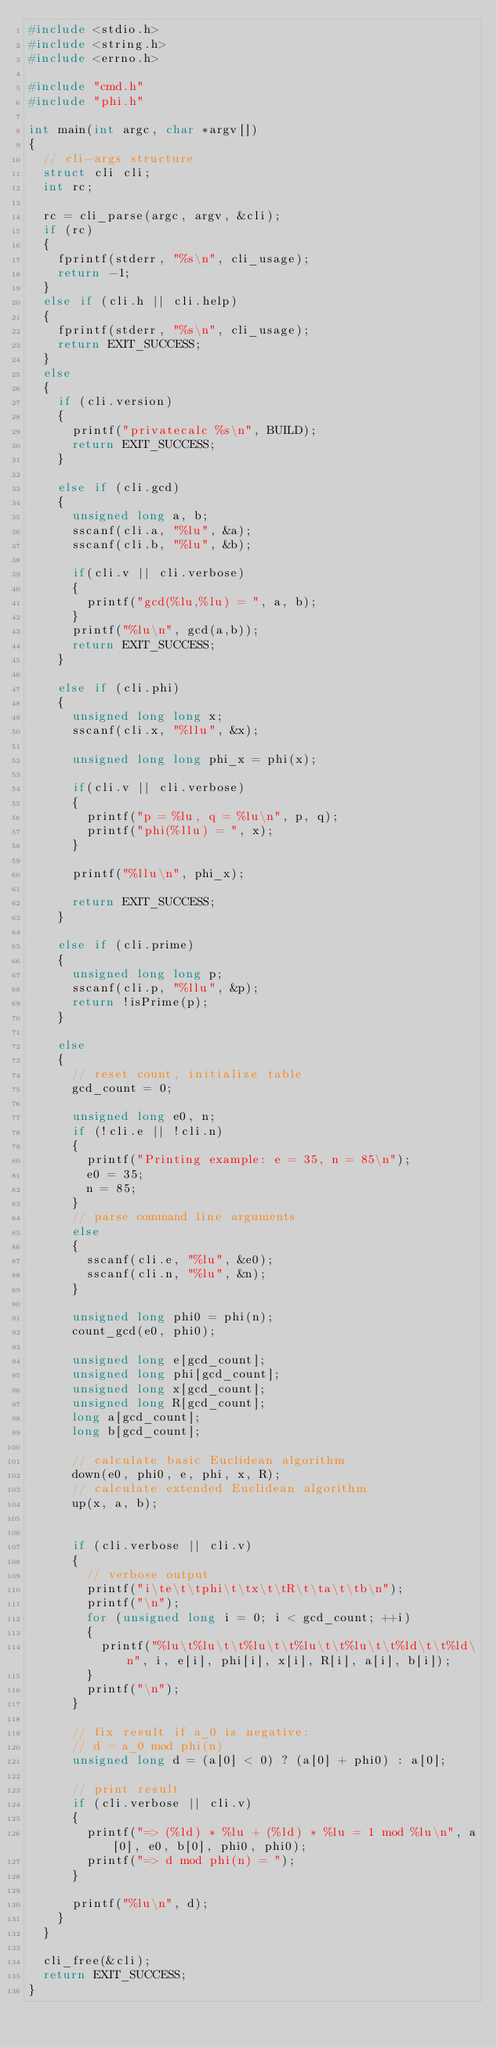Convert code to text. <code><loc_0><loc_0><loc_500><loc_500><_C_>#include <stdio.h>
#include <string.h>
#include <errno.h>

#include "cmd.h"
#include "phi.h"

int main(int argc, char *argv[])
{
  // cli-args structure
  struct cli cli;
  int rc;

  rc = cli_parse(argc, argv, &cli);
  if (rc)
  {
    fprintf(stderr, "%s\n", cli_usage);
    return -1;
  }
  else if (cli.h || cli.help)
  {
    fprintf(stderr, "%s\n", cli_usage);
    return EXIT_SUCCESS;
  }
  else
  {
    if (cli.version)
    {
      printf("privatecalc %s\n", BUILD);
      return EXIT_SUCCESS;
    }

    else if (cli.gcd)
    {
      unsigned long a, b;
      sscanf(cli.a, "%lu", &a);
      sscanf(cli.b, "%lu", &b);

      if(cli.v || cli.verbose)
      {
        printf("gcd(%lu,%lu) = ", a, b);
      }
      printf("%lu\n", gcd(a,b));
      return EXIT_SUCCESS;
    }

    else if (cli.phi)
    {
      unsigned long long x;
      sscanf(cli.x, "%llu", &x);

      unsigned long long phi_x = phi(x);

      if(cli.v || cli.verbose)
      {
        printf("p = %lu, q = %lu\n", p, q);
        printf("phi(%llu) = ", x);
      }

      printf("%llu\n", phi_x);

      return EXIT_SUCCESS;
    }

    else if (cli.prime)
    {
      unsigned long long p;
      sscanf(cli.p, "%llu", &p);
      return !isPrime(p);
    }

    else
    {
      // reset count, initialize table
      gcd_count = 0;

      unsigned long e0, n;
      if (!cli.e || !cli.n)
      {
        printf("Printing example: e = 35, n = 85\n");
        e0 = 35;
        n = 85;
      }
      // parse command line arguments
      else
      {
        sscanf(cli.e, "%lu", &e0);
        sscanf(cli.n, "%lu", &n);
      }

      unsigned long phi0 = phi(n);
      count_gcd(e0, phi0);

      unsigned long e[gcd_count];
      unsigned long phi[gcd_count];
      unsigned long x[gcd_count];
      unsigned long R[gcd_count];
      long a[gcd_count];
      long b[gcd_count];

      // calculate basic Euclidean algorithm
      down(e0, phi0, e, phi, x, R);
      // calculate extended Euclidean algorithm
      up(x, a, b);


      if (cli.verbose || cli.v)
      {
        // verbose output
        printf("i\te\t\tphi\t\tx\t\tR\t\ta\t\tb\n");
        printf("\n");
        for (unsigned long i = 0; i < gcd_count; ++i)
        {
          printf("%lu\t%lu\t\t%lu\t\t%lu\t\t%lu\t\t%ld\t\t%ld\n", i, e[i], phi[i], x[i], R[i], a[i], b[i]);
        }
        printf("\n");
      }

      // fix result if a_0 is negative:
      // d = a_0 mod phi(n)
      unsigned long d = (a[0] < 0) ? (a[0] + phi0) : a[0];

      // print result
      if (cli.verbose || cli.v)
      {
        printf("=> (%ld) * %lu + (%ld) * %lu = 1 mod %lu\n", a[0], e0, b[0], phi0, phi0);
        printf("=> d mod phi(n) = ");
      }

      printf("%lu\n", d);
    }
  }

  cli_free(&cli);
  return EXIT_SUCCESS;
}

</code> 